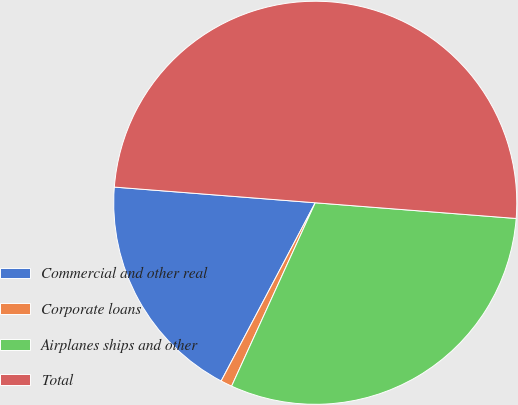<chart> <loc_0><loc_0><loc_500><loc_500><pie_chart><fcel>Commercial and other real<fcel>Corporate loans<fcel>Airplanes ships and other<fcel>Total<nl><fcel>18.51%<fcel>0.92%<fcel>30.57%<fcel>50.0%<nl></chart> 